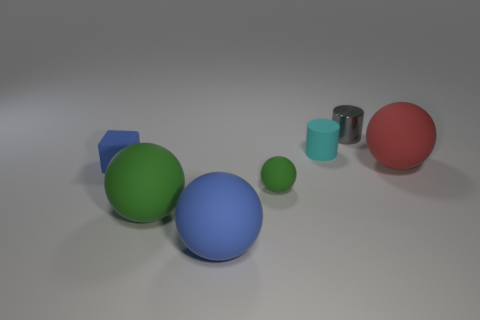How many green objects are tiny rubber things or metallic cylinders?
Offer a very short reply. 1. Does the small green object have the same shape as the big object behind the tiny matte ball?
Keep it short and to the point. Yes. What is the shape of the gray object?
Keep it short and to the point. Cylinder. There is a blue ball that is the same size as the red thing; what material is it?
Ensure brevity in your answer.  Rubber. Is there anything else that is the same size as the gray thing?
Offer a very short reply. Yes. How many things are brown balls or small things that are in front of the red ball?
Offer a terse response. 2. There is a cylinder that is the same material as the blue cube; what is its size?
Give a very brief answer. Small. The small thing that is right of the tiny matte thing that is behind the red rubber thing is what shape?
Ensure brevity in your answer.  Cylinder. There is a sphere that is on the right side of the blue rubber sphere and left of the tiny gray cylinder; what size is it?
Offer a terse response. Small. Is there a small blue matte thing that has the same shape as the large blue object?
Offer a very short reply. No. 